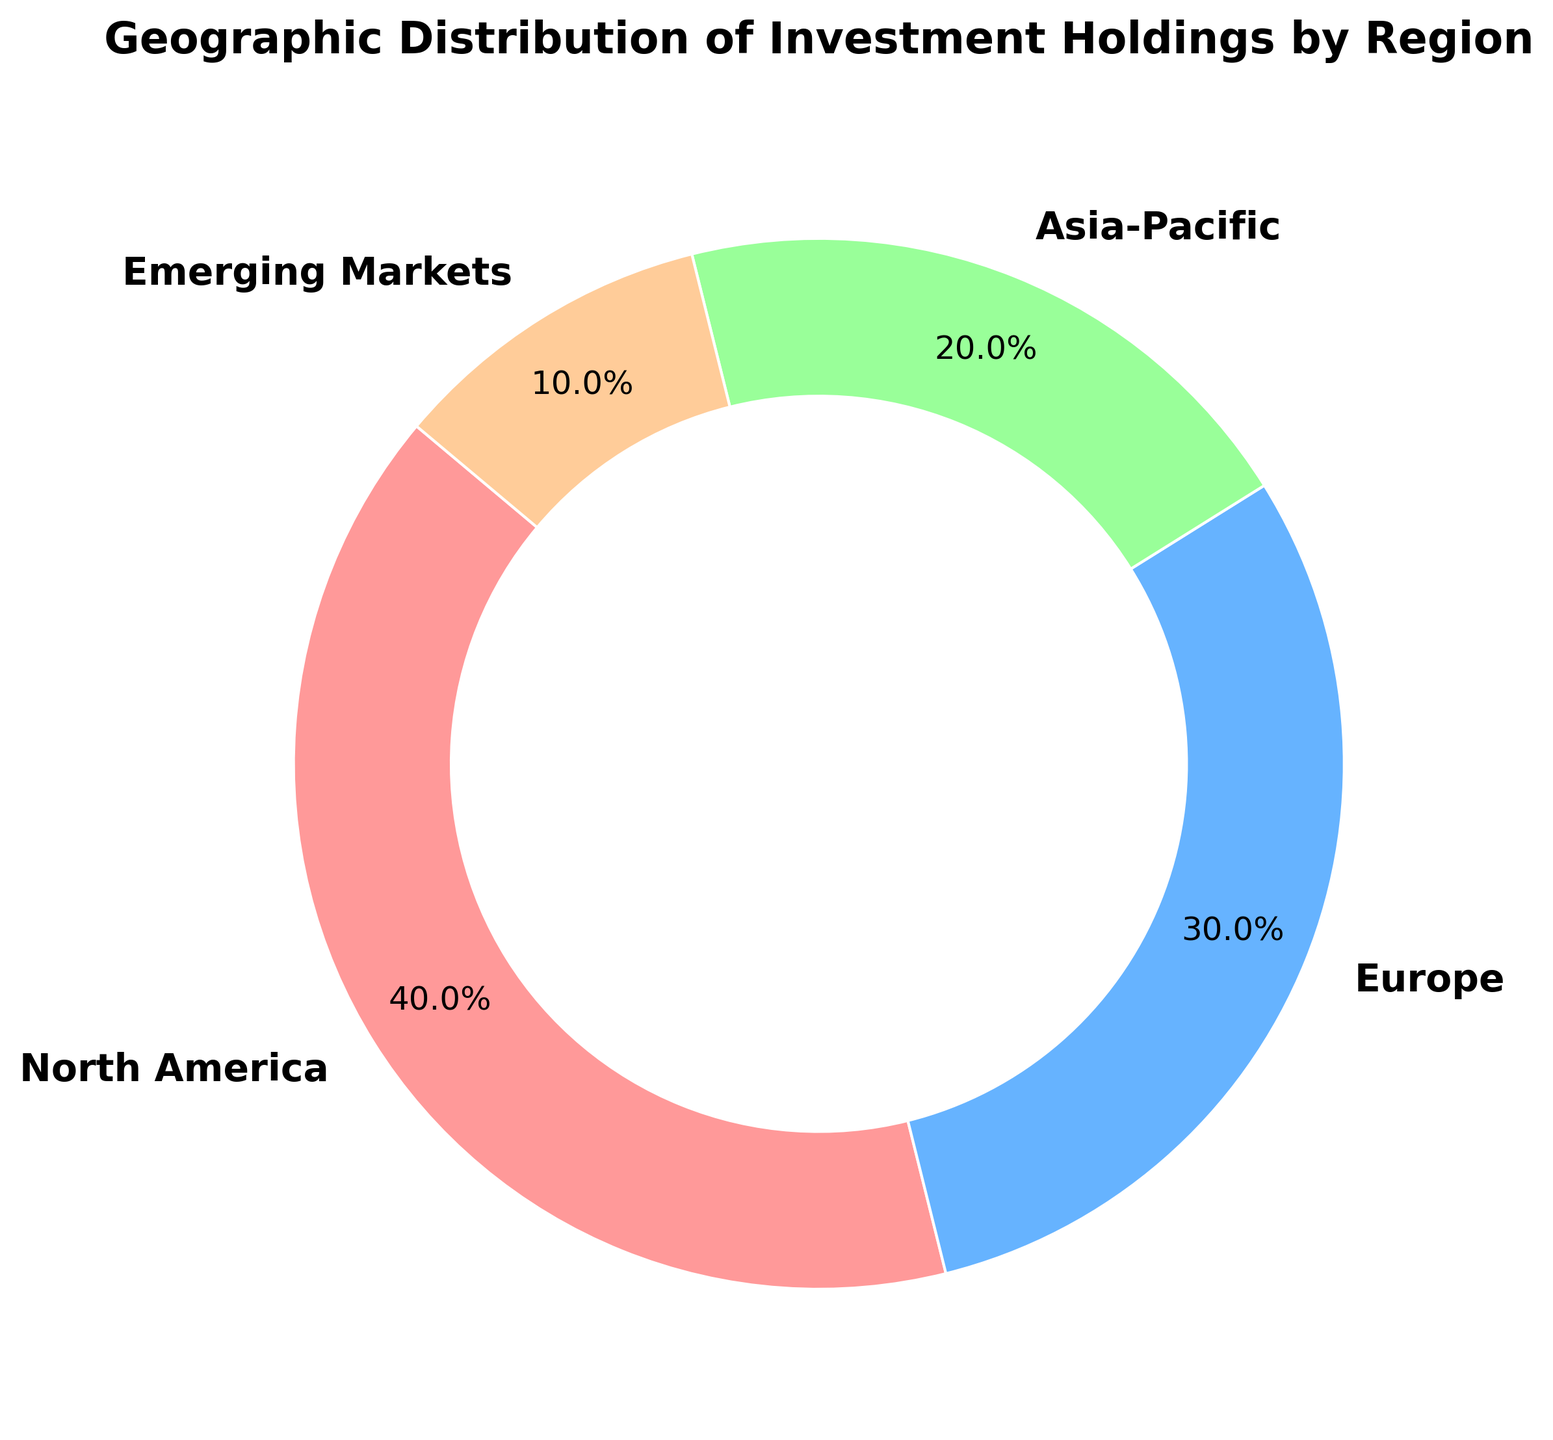What's the percentage of investment holdings in North America? The ring chart shows the percentage value for each region. For North America, it's labeled directly on the chart as 40%.
Answer: 40% Which region has the lowest investment holdings and what is its percentage? The ring chart clearly labels each region’s percentage, and Emerging Markets is listed with the lowest percentage at 10%.
Answer: Emerging Markets at 10% What is the combined percentage of investment holdings in Europe and Asia-Pacific? Identify the percentage values for Europe (30%) and Asia-Pacific (20%) from the chart and sum them up: 30% + 20% = 50%.
Answer: 50% Which two regions have a combined percentage closest to North America's percentage? North America holds 40%. Summing the percentages of other regions, Europe (30%) and Emerging Markets (10%) together equal 40%, exactly matching North America's percentage.
Answer: Europe and Emerging Markets Is the investment in Europe greater than that in Asia-Pacific? By how much? From the chart, Europe holds 30% and Asia-Pacific holds 20%. Subtracting these percentages: 30% - 20% equals 10%.
Answer: Yes, by 10% What regions' combined percentage of investment holdings is exactly the same as the percentage of investment in Emerging Markets? Emerging Markets has 10%. Summing other regions’ smallest percentages, Asia-Pacific (20%) is already greater, so no smaller regions could match Emerging Markets.
Answer: None What percentage of investment holdings is concentrated outside of North America? Subtract North America's percentage (40%) from 100%: 100% - 40% = 60%.
Answer: 60% Which region is represented by the light blue color on the chart? The chart uses specific colors for each region. The light blue color corresponds to Europe, which is labeled directly.
Answer: Europe What's the difference between the highest and lowest investment percentages? The highest is North America at 40%, and the lowest is Emerging Markets at 10%. Subtract these: 40% - 10% = 30%.
Answer: 30% If an investor wanted to evenly distribute 60% of their portfolio across Asia-Pacific and Emerging Markets, what proportion should go to each? Distribute 60% equally between the two regions: 60% divided by 2 equals 30% each.
Answer: 30% each 